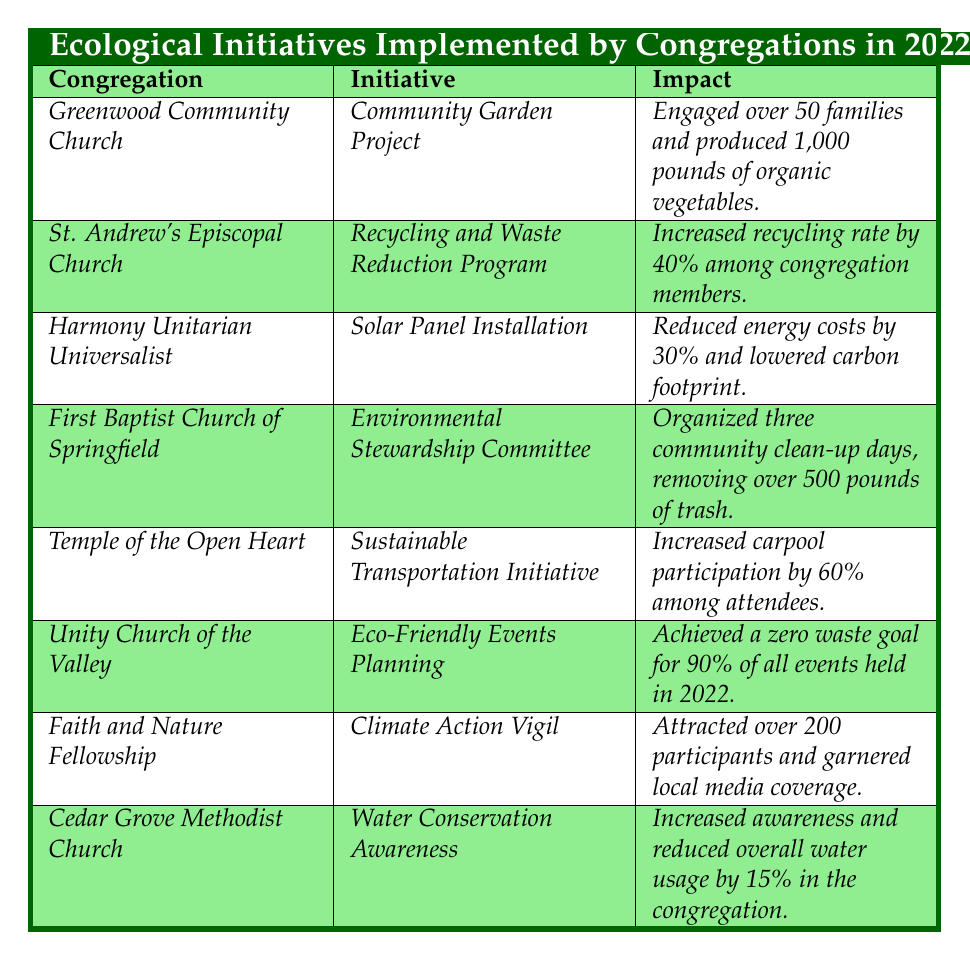What ecological initiative did the Harmony Unitarian Universalist implement in 2022? The table lists the initiatives by congregation name, and Harmony Unitarian Universalist's initiative is the Solar Panel Installation.
Answer: Solar Panel Installation Which congregation engaged over 200 participants for their initiative? Looking through the table, the Faith and Nature Fellowship is the congregation that organized a Climate Action Vigil and attracted over 200 participants.
Answer: Faith and Nature Fellowship Did the Unity Church of the Valley achieve a zero waste goal for their events? According to the impact stated, Unity Church of the Valley achieved a zero waste goal for 90% of all events held in 2022, which confirms that yes, they did achieve this goal.
Answer: Yes How many pounds of trash were removed by the First Baptist Church of Springfield during their clean-up days? The table shows that the Environmental Stewardship Committee organized three community clean-up days and removed over 500 pounds of trash. Thus, the specific amount is 500 pounds or more.
Answer: Over 500 pounds What was the average percentage of increased recycling rates for congregations that implemented waste reduction programs? The only congregation listed with a waste reduction program is St. Andrew's Episcopal Church, which increased its recycling rate by 40%. Since there's only one value to consider, the average is the same.
Answer: 40% Which initiative had the most direct impact on energy costs? The table details that Harmony Unitarian Universalist's initiative, Solar Panel Installation, specifically mentions a reduction in energy costs by 30%. No other initiative directly states an impact on energy costs in the same manner.
Answer: Solar Panel Installation If you combine the impact figures from the Cedar Grove Methodist Church and the Greenwood Community Church, what is the total impact regarding water usage and organic vegetable production? Cedar Grove Methodist Church reduced overall water usage by 15%, and Greenwood Community Church produced 1,000 pounds of organic vegetables. The total impact, while different in metrics, can be described as 1,000 pounds and a 15% reduction in water usage.
Answer: 1,000 pounds and 15% reduction Which congregation had the lowest engagement with their initiative compared to others? Reviewing the impacts listed, Greenwood Community Church engaged over 50 families, while most others report higher participation or impact. This suggests that, relative to the other initiatives, it had the lowest engagement.
Answer: Greenwood Community Church What percentage increase in carpool participation was noted at the Temple of the Open Heart? The impact states that carpool participation increased by 60% among attendees, indicating a significant move towards sustainable transportation.
Answer: 60% Which congregation focused primarily on education regarding water conservation? The Cedar Grove Methodist Church launched a campaign specifically to educate members about water conservation practices, indicating their primary focus was on education.
Answer: Cedar Grove Methodist Church 